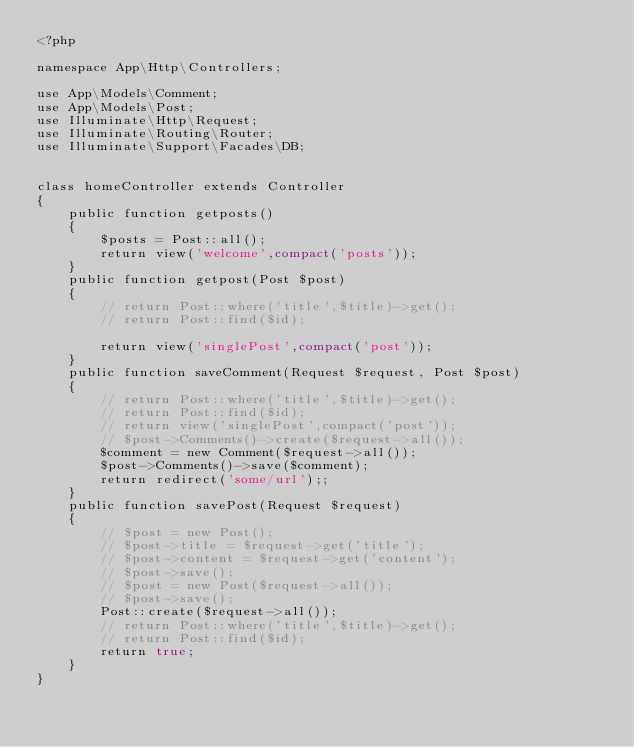Convert code to text. <code><loc_0><loc_0><loc_500><loc_500><_PHP_><?php

namespace App\Http\Controllers;

use App\Models\Comment;
use App\Models\Post;
use Illuminate\Http\Request;
use Illuminate\Routing\Router;
use Illuminate\Support\Facades\DB;


class homeController extends Controller
{
    public function getposts()
    {
        $posts = Post::all();
        return view('welcome',compact('posts'));
    }
    public function getpost(Post $post)
    {
        // return Post::where('title',$title)->get();
        // return Post::find($id);

        return view('singlePost',compact('post'));
    }
    public function saveComment(Request $request, Post $post)
    {
        // return Post::where('title',$title)->get();
        // return Post::find($id);
        // return view('singlePost',compact('post'));
        // $post->Comments()->create($request->all());
        $comment = new Comment($request->all());
        $post->Comments()->save($comment);
        return redirect('some/url');;
    }
    public function savePost(Request $request)
    {
        // $post = new Post();
        // $post->title = $request->get('title');
        // $post->content = $request->get('content');
        // $post->save();
        // $post = new Post($request->all());
        // $post->save();
        Post::create($request->all());
        // return Post::where('title',$title)->get();
        // return Post::find($id);
        return true;
    }
}
</code> 